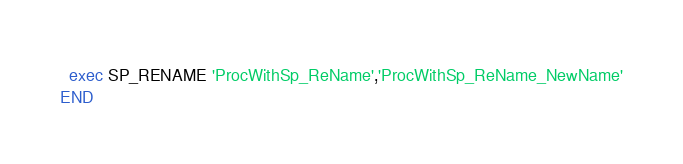Convert code to text. <code><loc_0><loc_0><loc_500><loc_500><_SQL_>  exec SP_RENAME 'ProcWithSp_ReName','ProcWithSp_ReName_NewName'
END</code> 